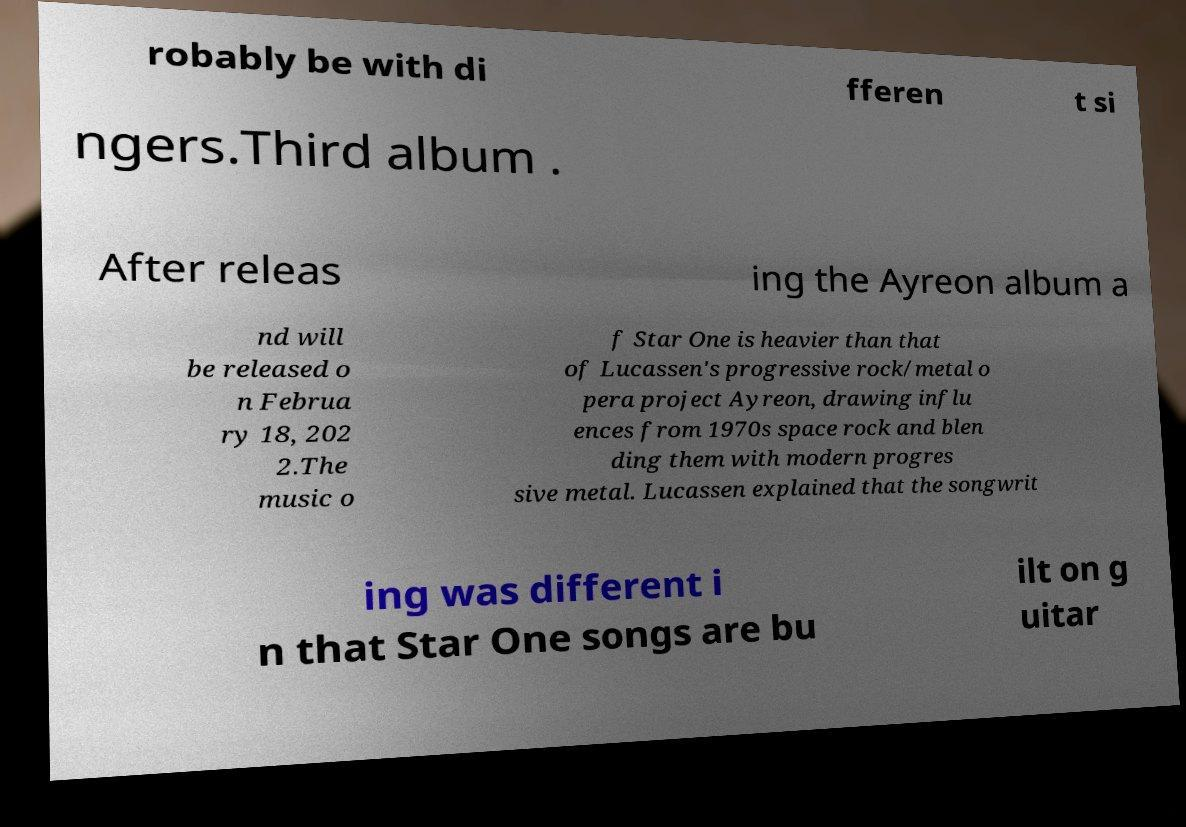Could you assist in decoding the text presented in this image and type it out clearly? robably be with di fferen t si ngers.Third album . After releas ing the Ayreon album a nd will be released o n Februa ry 18, 202 2.The music o f Star One is heavier than that of Lucassen's progressive rock/metal o pera project Ayreon, drawing influ ences from 1970s space rock and blen ding them with modern progres sive metal. Lucassen explained that the songwrit ing was different i n that Star One songs are bu ilt on g uitar 